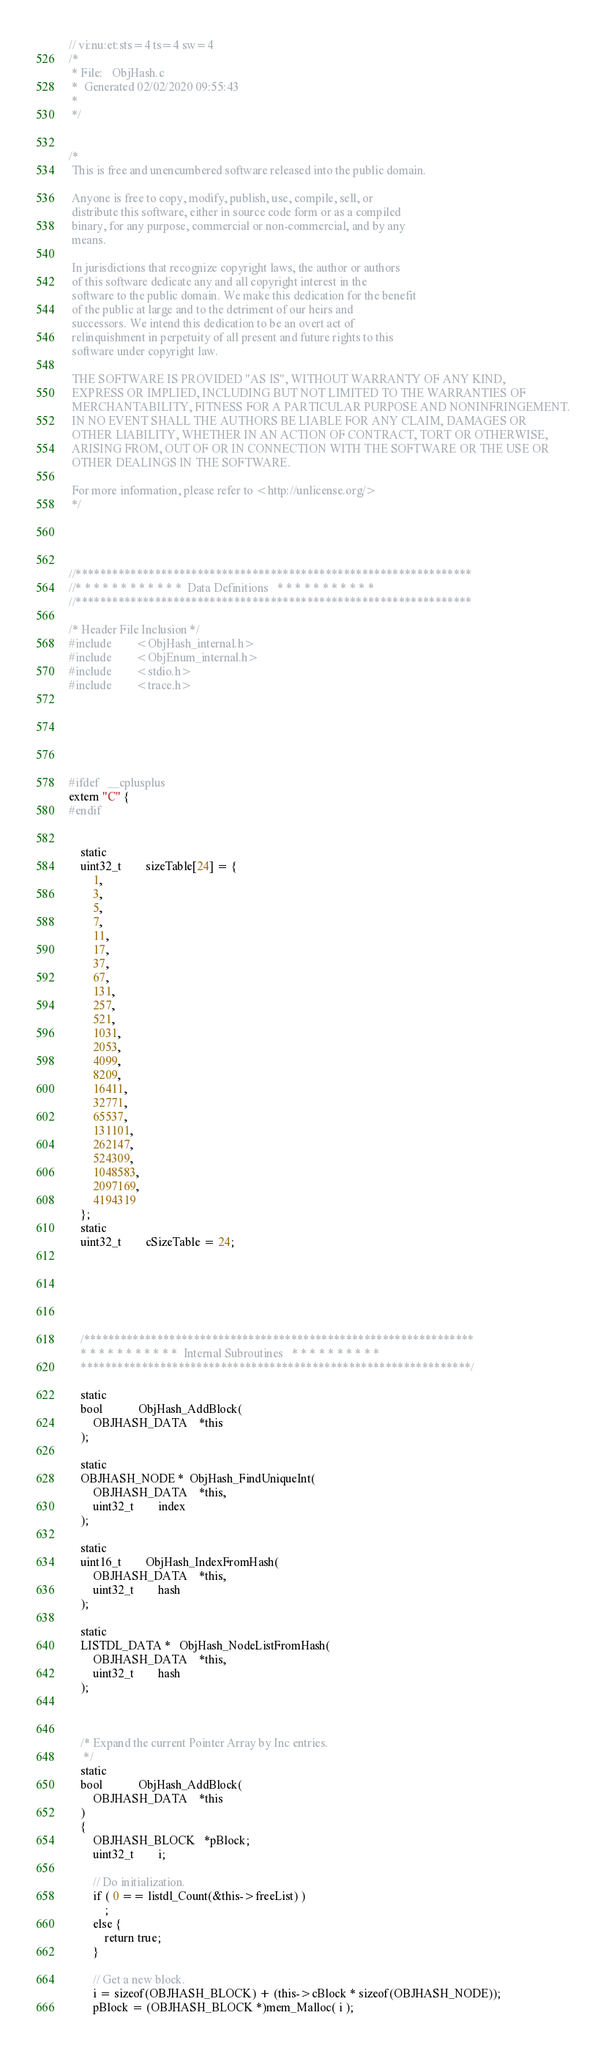<code> <loc_0><loc_0><loc_500><loc_500><_C_>// vi:nu:et:sts=4 ts=4 sw=4
/*
 * File:   ObjHash.c
 *	Generated 02/02/2020 09:55:43
 *
 */

 
/*
 This is free and unencumbered software released into the public domain.
 
 Anyone is free to copy, modify, publish, use, compile, sell, or
 distribute this software, either in source code form or as a compiled
 binary, for any purpose, commercial or non-commercial, and by any
 means.
 
 In jurisdictions that recognize copyright laws, the author or authors
 of this software dedicate any and all copyright interest in the
 software to the public domain. We make this dedication for the benefit
 of the public at large and to the detriment of our heirs and
 successors. We intend this dedication to be an overt act of
 relinquishment in perpetuity of all present and future rights to this
 software under copyright law.
 
 THE SOFTWARE IS PROVIDED "AS IS", WITHOUT WARRANTY OF ANY KIND,
 EXPRESS OR IMPLIED, INCLUDING BUT NOT LIMITED TO THE WARRANTIES OF
 MERCHANTABILITY, FITNESS FOR A PARTICULAR PURPOSE AND NONINFRINGEMENT.
 IN NO EVENT SHALL THE AUTHORS BE LIABLE FOR ANY CLAIM, DAMAGES OR
 OTHER LIABILITY, WHETHER IN AN ACTION OF CONTRACT, TORT OR OTHERWISE,
 ARISING FROM, OUT OF OR IN CONNECTION WITH THE SOFTWARE OR THE USE OR
 OTHER DEALINGS IN THE SOFTWARE.
 
 For more information, please refer to <http://unlicense.org/>
 */




//*****************************************************************
//* * * * * * * * * * * *  Data Definitions   * * * * * * * * * * *
//*****************************************************************

/* Header File Inclusion */
#include        <ObjHash_internal.h>
#include        <ObjEnum_internal.h>
#include        <stdio.h>
#include        <trace.h>






#ifdef	__cplusplus
extern "C" {
#endif
    

    static
    uint32_t        sizeTable[24] = {
        1,
        3,
        5,
        7,
        11,
        17,
        37,
        67,
        131,
        257,
        521,
        1031,
        2053,
        4099,
        8209,
        16411,
        32771,
        65537,
        131101,
        262147,
        524309,
        1048583,
        2097169,
        4194319
    };
    static
    uint32_t        cSizeTable = 24;





 
    /****************************************************************
    * * * * * * * * * * *  Internal Subroutines   * * * * * * * * * *
    ****************************************************************/

    static
    bool            ObjHash_AddBlock(
        OBJHASH_DATA    *this
    );

    static
    OBJHASH_NODE *  ObjHash_FindUniqueInt(
        OBJHASH_DATA    *this,
        uint32_t        index
    );

    static
    uint16_t        ObjHash_IndexFromHash(
        OBJHASH_DATA    *this,
        uint32_t        hash
    );

    static
    LISTDL_DATA *   ObjHash_NodeListFromHash(
        OBJHASH_DATA    *this,
        uint32_t        hash
    );



    /* Expand the current Pointer Array by Inc entries.
     */
    static
    bool            ObjHash_AddBlock(
        OBJHASH_DATA    *this
    )
    {
        OBJHASH_BLOCK   *pBlock;
        uint32_t        i;

        // Do initialization.
        if ( 0 == listdl_Count(&this->freeList) )
            ;
        else {
            return true;
        }

        // Get a new block.
        i = sizeof(OBJHASH_BLOCK) + (this->cBlock * sizeof(OBJHASH_NODE));
        pBlock = (OBJHASH_BLOCK *)mem_Malloc( i );</code> 